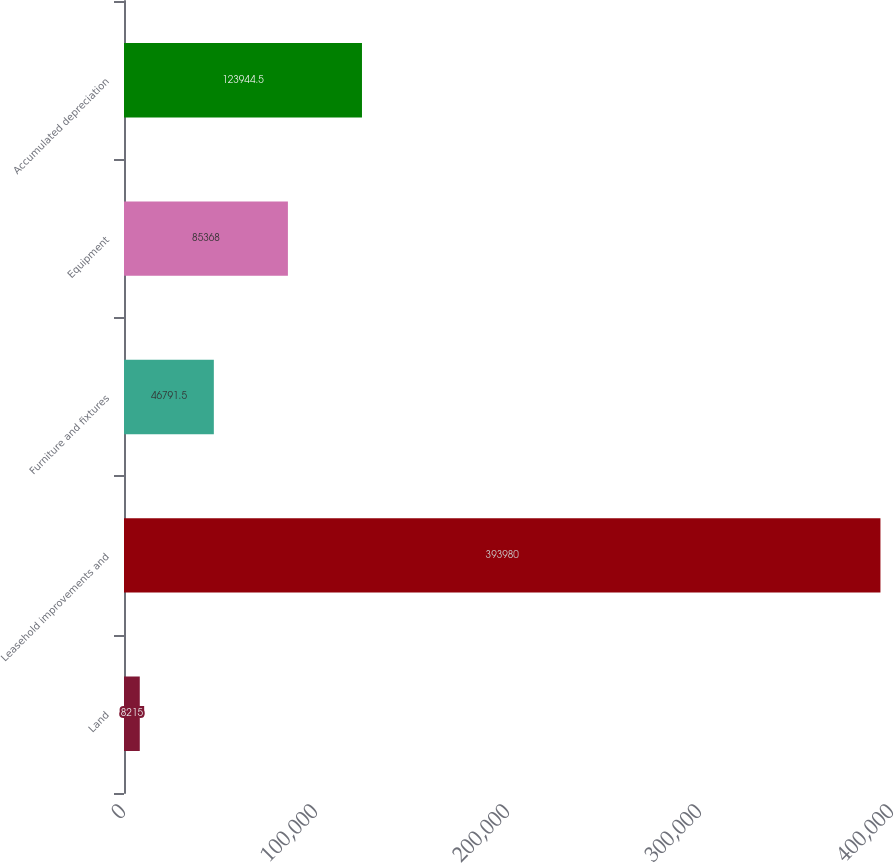<chart> <loc_0><loc_0><loc_500><loc_500><bar_chart><fcel>Land<fcel>Leasehold improvements and<fcel>Furniture and fixtures<fcel>Equipment<fcel>Accumulated depreciation<nl><fcel>8215<fcel>393980<fcel>46791.5<fcel>85368<fcel>123944<nl></chart> 